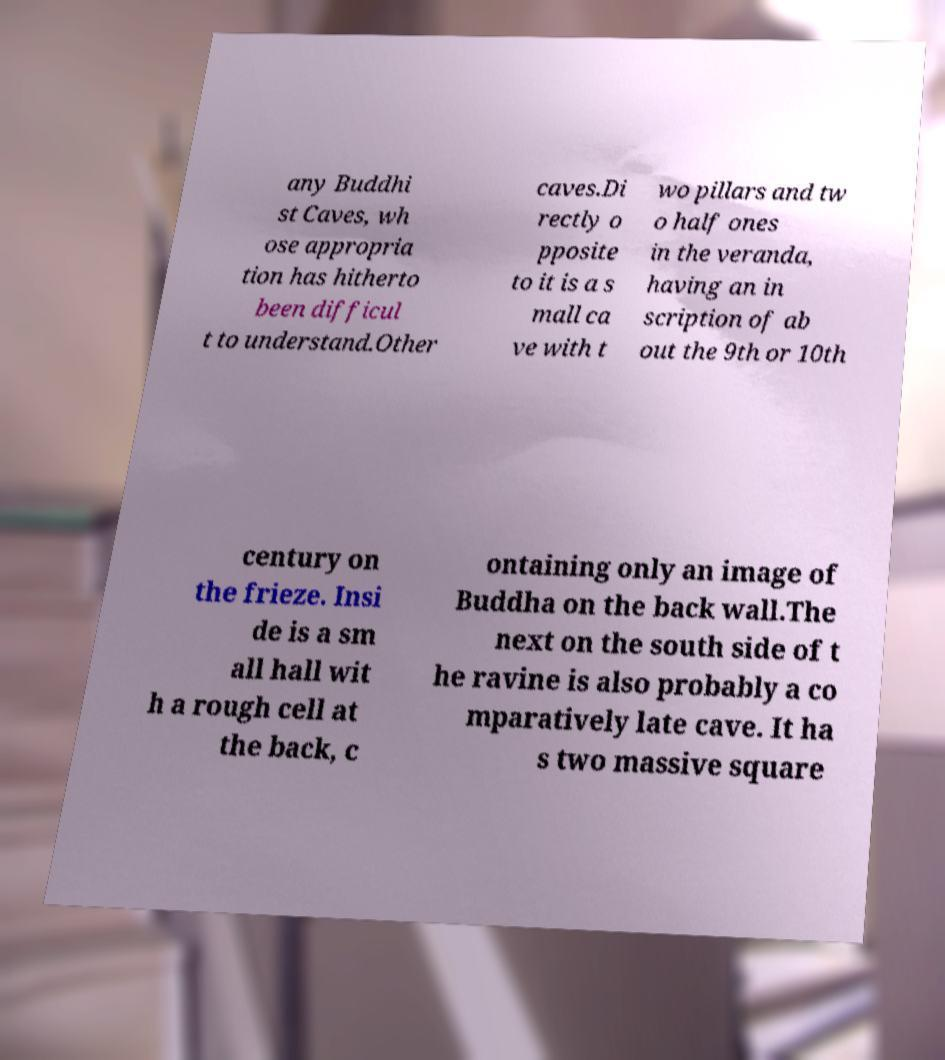What messages or text are displayed in this image? I need them in a readable, typed format. any Buddhi st Caves, wh ose appropria tion has hitherto been difficul t to understand.Other caves.Di rectly o pposite to it is a s mall ca ve with t wo pillars and tw o half ones in the veranda, having an in scription of ab out the 9th or 10th century on the frieze. Insi de is a sm all hall wit h a rough cell at the back, c ontaining only an image of Buddha on the back wall.The next on the south side of t he ravine is also probably a co mparatively late cave. It ha s two massive square 